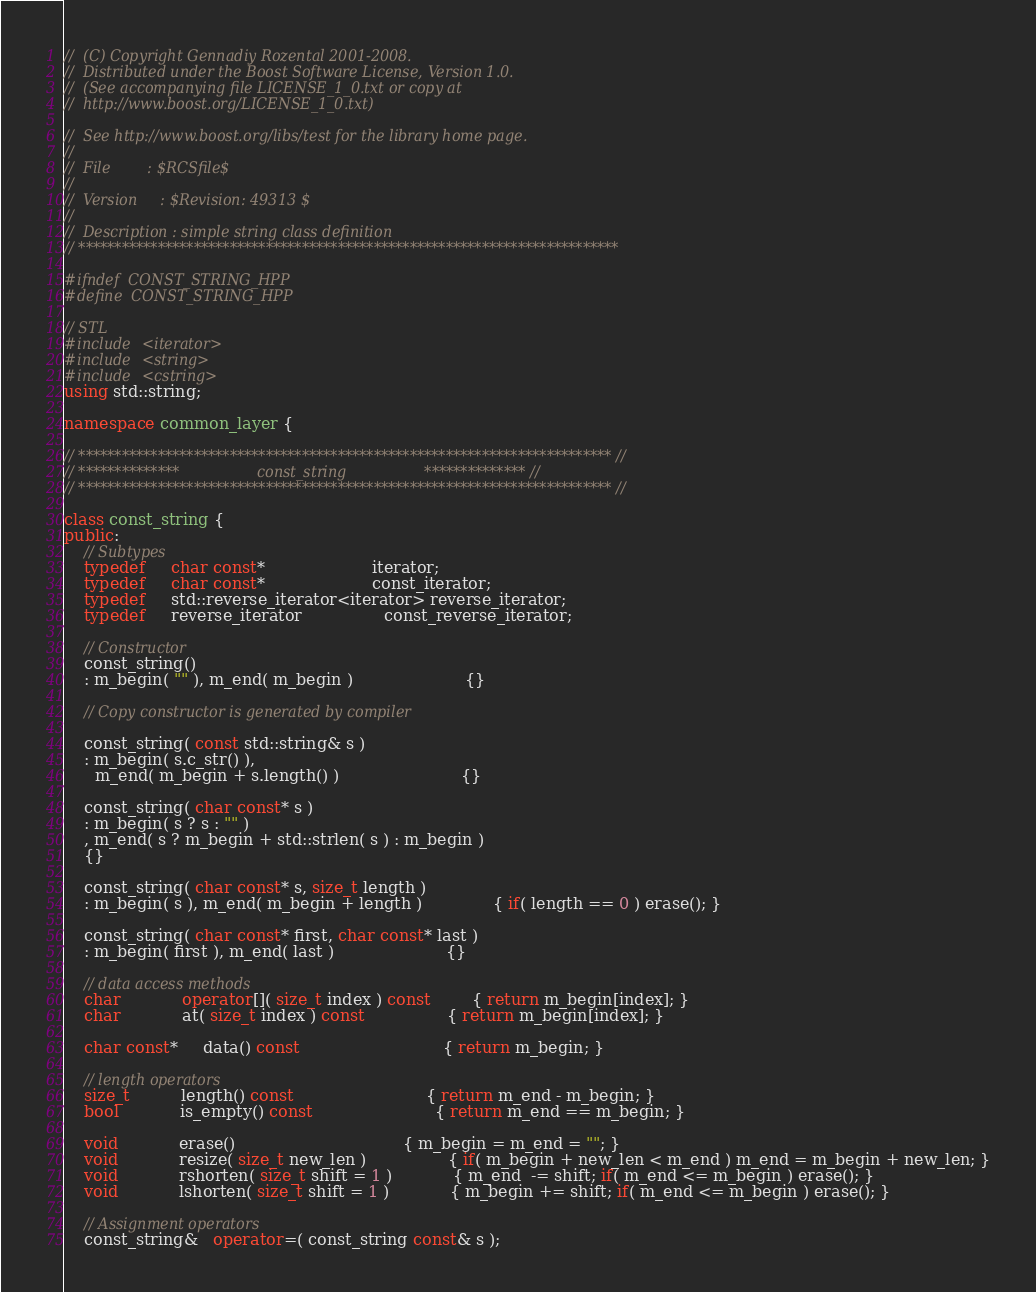<code> <loc_0><loc_0><loc_500><loc_500><_C++_>//  (C) Copyright Gennadiy Rozental 2001-2008.
//  Distributed under the Boost Software License, Version 1.0.
//  (See accompanying file LICENSE_1_0.txt or copy at 
//  http://www.boost.org/LICENSE_1_0.txt)

//  See http://www.boost.org/libs/test for the library home page.
//
//  File        : $RCSfile$
//
//  Version     : $Revision: 49313 $
//
//  Description : simple string class definition
// ***************************************************************************

#ifndef  CONST_STRING_HPP
#define  CONST_STRING_HPP

// STL
#include <iterator>
#include <string>
#include <cstring>
using std::string;

namespace common_layer {

// ************************************************************************** //
// **************                 const_string                 ************** //
// ************************************************************************** //

class const_string {
public:
    // Subtypes
    typedef     char const*                     iterator;
    typedef     char const*                     const_iterator;
    typedef     std::reverse_iterator<iterator> reverse_iterator;
    typedef     reverse_iterator                const_reverse_iterator;

    // Constructor
    const_string()
    : m_begin( "" ), m_end( m_begin )                      {}

    // Copy constructor is generated by compiler

    const_string( const std::string& s )
    : m_begin( s.c_str() ),
      m_end( m_begin + s.length() )                        {}

    const_string( char const* s )
    : m_begin( s ? s : "" )
    , m_end( s ? m_begin + std::strlen( s ) : m_begin )
    {}

    const_string( char const* s, size_t length )
    : m_begin( s ), m_end( m_begin + length )              { if( length == 0 ) erase(); }

    const_string( char const* first, char const* last )
    : m_begin( first ), m_end( last )                      {}

    // data access methods
    char            operator[]( size_t index ) const        { return m_begin[index]; }
    char            at( size_t index ) const                { return m_begin[index]; }

    char const*     data() const                            { return m_begin; }

    // length operators
    size_t          length() const                          { return m_end - m_begin; }
    bool            is_empty() const                        { return m_end == m_begin; }

    void            erase()                                 { m_begin = m_end = ""; }
    void            resize( size_t new_len )                { if( m_begin + new_len < m_end ) m_end = m_begin + new_len; }
    void            rshorten( size_t shift = 1 )            { m_end  -= shift; if( m_end <= m_begin ) erase(); }
    void            lshorten( size_t shift = 1 )            { m_begin += shift; if( m_end <= m_begin ) erase(); }

    // Assignment operators
    const_string&   operator=( const_string const& s );</code> 